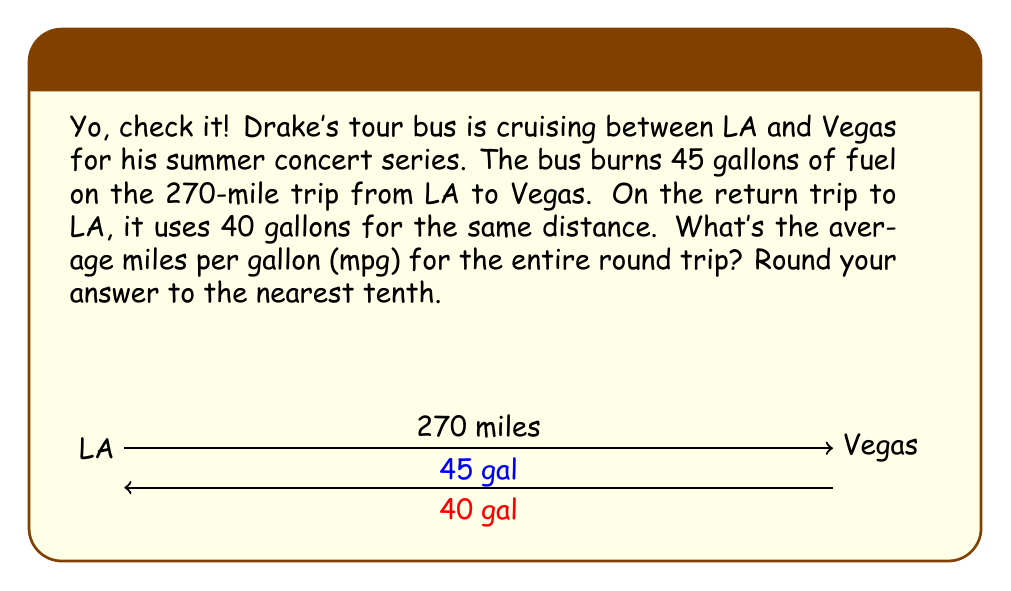Can you answer this question? Let's break it down, fam:

1) First, we need to calculate the total distance traveled:
   $$\text{Total distance} = 270 \text{ miles} + 270 \text{ miles} = 540 \text{ miles}$$

2) Next, we'll find the total fuel used:
   $$\text{Total fuel} = 45 \text{ gallons} + 40 \text{ gallons} = 85 \text{ gallons}$$

3) Now, we can use the formula for fuel efficiency:
   $$\text{Fuel Efficiency} = \frac{\text{Total distance}}{\text{Total fuel}}$$

4) Let's plug in our values:
   $$\text{Fuel Efficiency} = \frac{540 \text{ miles}}{85 \text{ gallons}}$$

5) Simplify the fraction:
   $$\text{Fuel Efficiency} = \frac{540}{85} \approx 6.3529 \text{ mpg}$$

6) Rounding to the nearest tenth:
   $$\text{Fuel Efficiency} \approx 6.4 \text{ mpg}$$

That's the average fuel efficiency for the entire round trip, yo!
Answer: $6.4 \text{ mpg}$ 